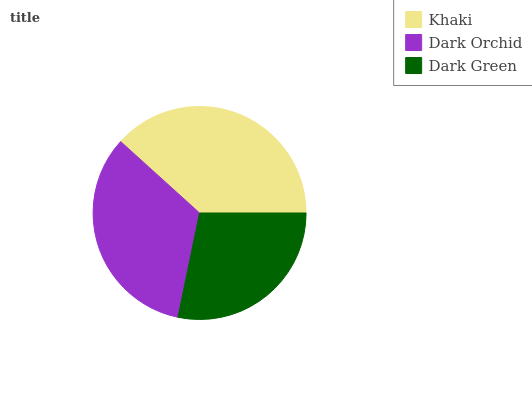Is Dark Green the minimum?
Answer yes or no. Yes. Is Khaki the maximum?
Answer yes or no. Yes. Is Dark Orchid the minimum?
Answer yes or no. No. Is Dark Orchid the maximum?
Answer yes or no. No. Is Khaki greater than Dark Orchid?
Answer yes or no. Yes. Is Dark Orchid less than Khaki?
Answer yes or no. Yes. Is Dark Orchid greater than Khaki?
Answer yes or no. No. Is Khaki less than Dark Orchid?
Answer yes or no. No. Is Dark Orchid the high median?
Answer yes or no. Yes. Is Dark Orchid the low median?
Answer yes or no. Yes. Is Dark Green the high median?
Answer yes or no. No. Is Dark Green the low median?
Answer yes or no. No. 